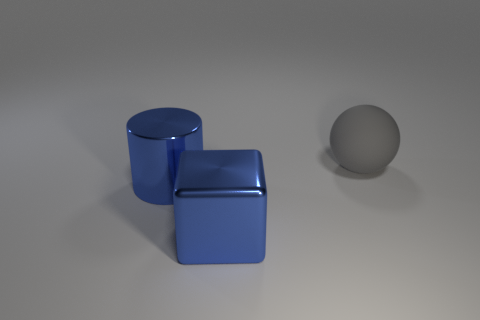Add 3 large gray cylinders. How many objects exist? 6 Subtract all cylinders. How many objects are left? 2 Subtract 0 green blocks. How many objects are left? 3 Subtract all large blue blocks. Subtract all big gray rubber objects. How many objects are left? 1 Add 1 blue metallic blocks. How many blue metallic blocks are left? 2 Add 2 tiny rubber objects. How many tiny rubber objects exist? 2 